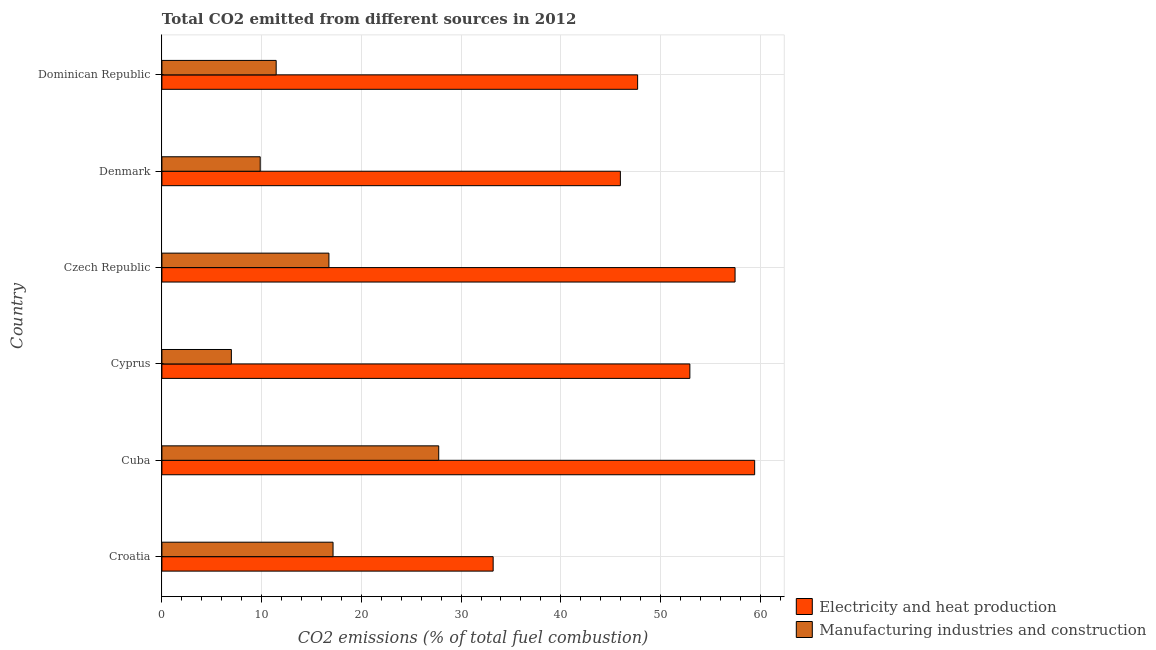How many groups of bars are there?
Provide a short and direct response. 6. Are the number of bars per tick equal to the number of legend labels?
Make the answer very short. Yes. Are the number of bars on each tick of the Y-axis equal?
Offer a very short reply. Yes. How many bars are there on the 2nd tick from the top?
Your answer should be compact. 2. What is the label of the 5th group of bars from the top?
Your answer should be very brief. Cuba. What is the co2 emissions due to manufacturing industries in Croatia?
Your answer should be compact. 17.16. Across all countries, what is the maximum co2 emissions due to electricity and heat production?
Ensure brevity in your answer.  59.44. Across all countries, what is the minimum co2 emissions due to manufacturing industries?
Your answer should be very brief. 6.97. In which country was the co2 emissions due to manufacturing industries maximum?
Offer a terse response. Cuba. In which country was the co2 emissions due to manufacturing industries minimum?
Offer a terse response. Cyprus. What is the total co2 emissions due to electricity and heat production in the graph?
Your response must be concise. 296.75. What is the difference between the co2 emissions due to manufacturing industries in Cyprus and that in Denmark?
Make the answer very short. -2.89. What is the difference between the co2 emissions due to manufacturing industries in Czech Republic and the co2 emissions due to electricity and heat production in Cyprus?
Make the answer very short. -36.19. What is the average co2 emissions due to electricity and heat production per country?
Your answer should be very brief. 49.46. What is the difference between the co2 emissions due to electricity and heat production and co2 emissions due to manufacturing industries in Cuba?
Your response must be concise. 31.68. In how many countries, is the co2 emissions due to electricity and heat production greater than 22 %?
Your answer should be very brief. 6. What is the ratio of the co2 emissions due to electricity and heat production in Cuba to that in Dominican Republic?
Your answer should be very brief. 1.25. Is the co2 emissions due to electricity and heat production in Croatia less than that in Dominican Republic?
Keep it short and to the point. Yes. Is the difference between the co2 emissions due to electricity and heat production in Cyprus and Dominican Republic greater than the difference between the co2 emissions due to manufacturing industries in Cyprus and Dominican Republic?
Provide a succinct answer. Yes. What is the difference between the highest and the second highest co2 emissions due to electricity and heat production?
Your response must be concise. 1.96. What is the difference between the highest and the lowest co2 emissions due to manufacturing industries?
Ensure brevity in your answer.  20.79. What does the 2nd bar from the top in Denmark represents?
Offer a very short reply. Electricity and heat production. What does the 2nd bar from the bottom in Croatia represents?
Give a very brief answer. Manufacturing industries and construction. How many countries are there in the graph?
Provide a short and direct response. 6. Does the graph contain any zero values?
Ensure brevity in your answer.  No. Does the graph contain grids?
Offer a terse response. Yes. How many legend labels are there?
Provide a succinct answer. 2. What is the title of the graph?
Make the answer very short. Total CO2 emitted from different sources in 2012. Does "Secondary school" appear as one of the legend labels in the graph?
Your answer should be compact. No. What is the label or title of the X-axis?
Offer a terse response. CO2 emissions (% of total fuel combustion). What is the CO2 emissions (% of total fuel combustion) of Electricity and heat production in Croatia?
Your answer should be very brief. 33.22. What is the CO2 emissions (% of total fuel combustion) of Manufacturing industries and construction in Croatia?
Provide a succinct answer. 17.16. What is the CO2 emissions (% of total fuel combustion) in Electricity and heat production in Cuba?
Keep it short and to the point. 59.44. What is the CO2 emissions (% of total fuel combustion) in Manufacturing industries and construction in Cuba?
Provide a short and direct response. 27.76. What is the CO2 emissions (% of total fuel combustion) of Electricity and heat production in Cyprus?
Your answer should be compact. 52.94. What is the CO2 emissions (% of total fuel combustion) of Manufacturing industries and construction in Cyprus?
Offer a terse response. 6.97. What is the CO2 emissions (% of total fuel combustion) of Electricity and heat production in Czech Republic?
Offer a terse response. 57.47. What is the CO2 emissions (% of total fuel combustion) of Manufacturing industries and construction in Czech Republic?
Give a very brief answer. 16.75. What is the CO2 emissions (% of total fuel combustion) in Electricity and heat production in Denmark?
Offer a very short reply. 45.97. What is the CO2 emissions (% of total fuel combustion) of Manufacturing industries and construction in Denmark?
Provide a succinct answer. 9.86. What is the CO2 emissions (% of total fuel combustion) in Electricity and heat production in Dominican Republic?
Your answer should be very brief. 47.7. What is the CO2 emissions (% of total fuel combustion) in Manufacturing industries and construction in Dominican Republic?
Keep it short and to the point. 11.46. Across all countries, what is the maximum CO2 emissions (% of total fuel combustion) in Electricity and heat production?
Offer a terse response. 59.44. Across all countries, what is the maximum CO2 emissions (% of total fuel combustion) of Manufacturing industries and construction?
Your response must be concise. 27.76. Across all countries, what is the minimum CO2 emissions (% of total fuel combustion) of Electricity and heat production?
Give a very brief answer. 33.22. Across all countries, what is the minimum CO2 emissions (% of total fuel combustion) in Manufacturing industries and construction?
Provide a succinct answer. 6.97. What is the total CO2 emissions (% of total fuel combustion) of Electricity and heat production in the graph?
Your answer should be compact. 296.75. What is the total CO2 emissions (% of total fuel combustion) in Manufacturing industries and construction in the graph?
Give a very brief answer. 89.95. What is the difference between the CO2 emissions (% of total fuel combustion) in Electricity and heat production in Croatia and that in Cuba?
Make the answer very short. -26.22. What is the difference between the CO2 emissions (% of total fuel combustion) of Manufacturing industries and construction in Croatia and that in Cuba?
Your answer should be compact. -10.6. What is the difference between the CO2 emissions (% of total fuel combustion) in Electricity and heat production in Croatia and that in Cyprus?
Your answer should be compact. -19.72. What is the difference between the CO2 emissions (% of total fuel combustion) of Manufacturing industries and construction in Croatia and that in Cyprus?
Offer a very short reply. 10.2. What is the difference between the CO2 emissions (% of total fuel combustion) in Electricity and heat production in Croatia and that in Czech Republic?
Your answer should be very brief. -24.26. What is the difference between the CO2 emissions (% of total fuel combustion) in Manufacturing industries and construction in Croatia and that in Czech Republic?
Offer a terse response. 0.41. What is the difference between the CO2 emissions (% of total fuel combustion) in Electricity and heat production in Croatia and that in Denmark?
Your answer should be very brief. -12.76. What is the difference between the CO2 emissions (% of total fuel combustion) in Manufacturing industries and construction in Croatia and that in Denmark?
Your answer should be compact. 7.3. What is the difference between the CO2 emissions (% of total fuel combustion) in Electricity and heat production in Croatia and that in Dominican Republic?
Make the answer very short. -14.49. What is the difference between the CO2 emissions (% of total fuel combustion) in Manufacturing industries and construction in Croatia and that in Dominican Republic?
Your response must be concise. 5.7. What is the difference between the CO2 emissions (% of total fuel combustion) in Electricity and heat production in Cuba and that in Cyprus?
Your answer should be compact. 6.5. What is the difference between the CO2 emissions (% of total fuel combustion) of Manufacturing industries and construction in Cuba and that in Cyprus?
Your response must be concise. 20.79. What is the difference between the CO2 emissions (% of total fuel combustion) of Electricity and heat production in Cuba and that in Czech Republic?
Make the answer very short. 1.96. What is the difference between the CO2 emissions (% of total fuel combustion) of Manufacturing industries and construction in Cuba and that in Czech Republic?
Provide a short and direct response. 11.01. What is the difference between the CO2 emissions (% of total fuel combustion) in Electricity and heat production in Cuba and that in Denmark?
Provide a short and direct response. 13.46. What is the difference between the CO2 emissions (% of total fuel combustion) in Manufacturing industries and construction in Cuba and that in Denmark?
Ensure brevity in your answer.  17.9. What is the difference between the CO2 emissions (% of total fuel combustion) of Electricity and heat production in Cuba and that in Dominican Republic?
Make the answer very short. 11.73. What is the difference between the CO2 emissions (% of total fuel combustion) of Manufacturing industries and construction in Cuba and that in Dominican Republic?
Provide a succinct answer. 16.3. What is the difference between the CO2 emissions (% of total fuel combustion) of Electricity and heat production in Cyprus and that in Czech Republic?
Make the answer very short. -4.53. What is the difference between the CO2 emissions (% of total fuel combustion) of Manufacturing industries and construction in Cyprus and that in Czech Republic?
Offer a terse response. -9.78. What is the difference between the CO2 emissions (% of total fuel combustion) of Electricity and heat production in Cyprus and that in Denmark?
Provide a short and direct response. 6.97. What is the difference between the CO2 emissions (% of total fuel combustion) of Manufacturing industries and construction in Cyprus and that in Denmark?
Your response must be concise. -2.89. What is the difference between the CO2 emissions (% of total fuel combustion) in Electricity and heat production in Cyprus and that in Dominican Republic?
Make the answer very short. 5.24. What is the difference between the CO2 emissions (% of total fuel combustion) of Manufacturing industries and construction in Cyprus and that in Dominican Republic?
Your answer should be very brief. -4.49. What is the difference between the CO2 emissions (% of total fuel combustion) of Electricity and heat production in Czech Republic and that in Denmark?
Offer a terse response. 11.5. What is the difference between the CO2 emissions (% of total fuel combustion) of Manufacturing industries and construction in Czech Republic and that in Denmark?
Offer a very short reply. 6.89. What is the difference between the CO2 emissions (% of total fuel combustion) of Electricity and heat production in Czech Republic and that in Dominican Republic?
Ensure brevity in your answer.  9.77. What is the difference between the CO2 emissions (% of total fuel combustion) in Manufacturing industries and construction in Czech Republic and that in Dominican Republic?
Provide a succinct answer. 5.29. What is the difference between the CO2 emissions (% of total fuel combustion) of Electricity and heat production in Denmark and that in Dominican Republic?
Offer a terse response. -1.73. What is the difference between the CO2 emissions (% of total fuel combustion) of Manufacturing industries and construction in Denmark and that in Dominican Republic?
Your response must be concise. -1.6. What is the difference between the CO2 emissions (% of total fuel combustion) in Electricity and heat production in Croatia and the CO2 emissions (% of total fuel combustion) in Manufacturing industries and construction in Cuba?
Provide a short and direct response. 5.46. What is the difference between the CO2 emissions (% of total fuel combustion) in Electricity and heat production in Croatia and the CO2 emissions (% of total fuel combustion) in Manufacturing industries and construction in Cyprus?
Your answer should be very brief. 26.25. What is the difference between the CO2 emissions (% of total fuel combustion) in Electricity and heat production in Croatia and the CO2 emissions (% of total fuel combustion) in Manufacturing industries and construction in Czech Republic?
Offer a terse response. 16.47. What is the difference between the CO2 emissions (% of total fuel combustion) in Electricity and heat production in Croatia and the CO2 emissions (% of total fuel combustion) in Manufacturing industries and construction in Denmark?
Provide a succinct answer. 23.36. What is the difference between the CO2 emissions (% of total fuel combustion) of Electricity and heat production in Croatia and the CO2 emissions (% of total fuel combustion) of Manufacturing industries and construction in Dominican Republic?
Keep it short and to the point. 21.76. What is the difference between the CO2 emissions (% of total fuel combustion) of Electricity and heat production in Cuba and the CO2 emissions (% of total fuel combustion) of Manufacturing industries and construction in Cyprus?
Your answer should be compact. 52.47. What is the difference between the CO2 emissions (% of total fuel combustion) of Electricity and heat production in Cuba and the CO2 emissions (% of total fuel combustion) of Manufacturing industries and construction in Czech Republic?
Provide a succinct answer. 42.69. What is the difference between the CO2 emissions (% of total fuel combustion) of Electricity and heat production in Cuba and the CO2 emissions (% of total fuel combustion) of Manufacturing industries and construction in Denmark?
Give a very brief answer. 49.58. What is the difference between the CO2 emissions (% of total fuel combustion) in Electricity and heat production in Cuba and the CO2 emissions (% of total fuel combustion) in Manufacturing industries and construction in Dominican Republic?
Give a very brief answer. 47.98. What is the difference between the CO2 emissions (% of total fuel combustion) in Electricity and heat production in Cyprus and the CO2 emissions (% of total fuel combustion) in Manufacturing industries and construction in Czech Republic?
Make the answer very short. 36.19. What is the difference between the CO2 emissions (% of total fuel combustion) in Electricity and heat production in Cyprus and the CO2 emissions (% of total fuel combustion) in Manufacturing industries and construction in Denmark?
Provide a succinct answer. 43.08. What is the difference between the CO2 emissions (% of total fuel combustion) of Electricity and heat production in Cyprus and the CO2 emissions (% of total fuel combustion) of Manufacturing industries and construction in Dominican Republic?
Provide a short and direct response. 41.48. What is the difference between the CO2 emissions (% of total fuel combustion) of Electricity and heat production in Czech Republic and the CO2 emissions (% of total fuel combustion) of Manufacturing industries and construction in Denmark?
Your answer should be very brief. 47.62. What is the difference between the CO2 emissions (% of total fuel combustion) of Electricity and heat production in Czech Republic and the CO2 emissions (% of total fuel combustion) of Manufacturing industries and construction in Dominican Republic?
Provide a short and direct response. 46.02. What is the difference between the CO2 emissions (% of total fuel combustion) in Electricity and heat production in Denmark and the CO2 emissions (% of total fuel combustion) in Manufacturing industries and construction in Dominican Republic?
Give a very brief answer. 34.51. What is the average CO2 emissions (% of total fuel combustion) of Electricity and heat production per country?
Ensure brevity in your answer.  49.46. What is the average CO2 emissions (% of total fuel combustion) of Manufacturing industries and construction per country?
Offer a terse response. 14.99. What is the difference between the CO2 emissions (% of total fuel combustion) of Electricity and heat production and CO2 emissions (% of total fuel combustion) of Manufacturing industries and construction in Croatia?
Make the answer very short. 16.06. What is the difference between the CO2 emissions (% of total fuel combustion) in Electricity and heat production and CO2 emissions (% of total fuel combustion) in Manufacturing industries and construction in Cuba?
Provide a short and direct response. 31.68. What is the difference between the CO2 emissions (% of total fuel combustion) of Electricity and heat production and CO2 emissions (% of total fuel combustion) of Manufacturing industries and construction in Cyprus?
Give a very brief answer. 45.98. What is the difference between the CO2 emissions (% of total fuel combustion) of Electricity and heat production and CO2 emissions (% of total fuel combustion) of Manufacturing industries and construction in Czech Republic?
Provide a short and direct response. 40.73. What is the difference between the CO2 emissions (% of total fuel combustion) of Electricity and heat production and CO2 emissions (% of total fuel combustion) of Manufacturing industries and construction in Denmark?
Offer a terse response. 36.12. What is the difference between the CO2 emissions (% of total fuel combustion) in Electricity and heat production and CO2 emissions (% of total fuel combustion) in Manufacturing industries and construction in Dominican Republic?
Give a very brief answer. 36.24. What is the ratio of the CO2 emissions (% of total fuel combustion) of Electricity and heat production in Croatia to that in Cuba?
Provide a succinct answer. 0.56. What is the ratio of the CO2 emissions (% of total fuel combustion) of Manufacturing industries and construction in Croatia to that in Cuba?
Your answer should be very brief. 0.62. What is the ratio of the CO2 emissions (% of total fuel combustion) of Electricity and heat production in Croatia to that in Cyprus?
Your answer should be very brief. 0.63. What is the ratio of the CO2 emissions (% of total fuel combustion) in Manufacturing industries and construction in Croatia to that in Cyprus?
Your answer should be very brief. 2.46. What is the ratio of the CO2 emissions (% of total fuel combustion) in Electricity and heat production in Croatia to that in Czech Republic?
Ensure brevity in your answer.  0.58. What is the ratio of the CO2 emissions (% of total fuel combustion) of Manufacturing industries and construction in Croatia to that in Czech Republic?
Provide a succinct answer. 1.02. What is the ratio of the CO2 emissions (% of total fuel combustion) in Electricity and heat production in Croatia to that in Denmark?
Provide a succinct answer. 0.72. What is the ratio of the CO2 emissions (% of total fuel combustion) of Manufacturing industries and construction in Croatia to that in Denmark?
Provide a succinct answer. 1.74. What is the ratio of the CO2 emissions (% of total fuel combustion) of Electricity and heat production in Croatia to that in Dominican Republic?
Provide a short and direct response. 0.7. What is the ratio of the CO2 emissions (% of total fuel combustion) of Manufacturing industries and construction in Croatia to that in Dominican Republic?
Keep it short and to the point. 1.5. What is the ratio of the CO2 emissions (% of total fuel combustion) in Electricity and heat production in Cuba to that in Cyprus?
Your response must be concise. 1.12. What is the ratio of the CO2 emissions (% of total fuel combustion) in Manufacturing industries and construction in Cuba to that in Cyprus?
Give a very brief answer. 3.98. What is the ratio of the CO2 emissions (% of total fuel combustion) in Electricity and heat production in Cuba to that in Czech Republic?
Ensure brevity in your answer.  1.03. What is the ratio of the CO2 emissions (% of total fuel combustion) of Manufacturing industries and construction in Cuba to that in Czech Republic?
Offer a terse response. 1.66. What is the ratio of the CO2 emissions (% of total fuel combustion) in Electricity and heat production in Cuba to that in Denmark?
Keep it short and to the point. 1.29. What is the ratio of the CO2 emissions (% of total fuel combustion) in Manufacturing industries and construction in Cuba to that in Denmark?
Your response must be concise. 2.82. What is the ratio of the CO2 emissions (% of total fuel combustion) of Electricity and heat production in Cuba to that in Dominican Republic?
Ensure brevity in your answer.  1.25. What is the ratio of the CO2 emissions (% of total fuel combustion) of Manufacturing industries and construction in Cuba to that in Dominican Republic?
Your answer should be compact. 2.42. What is the ratio of the CO2 emissions (% of total fuel combustion) in Electricity and heat production in Cyprus to that in Czech Republic?
Your answer should be very brief. 0.92. What is the ratio of the CO2 emissions (% of total fuel combustion) in Manufacturing industries and construction in Cyprus to that in Czech Republic?
Your answer should be very brief. 0.42. What is the ratio of the CO2 emissions (% of total fuel combustion) of Electricity and heat production in Cyprus to that in Denmark?
Keep it short and to the point. 1.15. What is the ratio of the CO2 emissions (% of total fuel combustion) of Manufacturing industries and construction in Cyprus to that in Denmark?
Offer a terse response. 0.71. What is the ratio of the CO2 emissions (% of total fuel combustion) of Electricity and heat production in Cyprus to that in Dominican Republic?
Keep it short and to the point. 1.11. What is the ratio of the CO2 emissions (% of total fuel combustion) of Manufacturing industries and construction in Cyprus to that in Dominican Republic?
Your response must be concise. 0.61. What is the ratio of the CO2 emissions (% of total fuel combustion) of Electricity and heat production in Czech Republic to that in Denmark?
Make the answer very short. 1.25. What is the ratio of the CO2 emissions (% of total fuel combustion) in Manufacturing industries and construction in Czech Republic to that in Denmark?
Your answer should be compact. 1.7. What is the ratio of the CO2 emissions (% of total fuel combustion) in Electricity and heat production in Czech Republic to that in Dominican Republic?
Your response must be concise. 1.2. What is the ratio of the CO2 emissions (% of total fuel combustion) of Manufacturing industries and construction in Czech Republic to that in Dominican Republic?
Give a very brief answer. 1.46. What is the ratio of the CO2 emissions (% of total fuel combustion) of Electricity and heat production in Denmark to that in Dominican Republic?
Keep it short and to the point. 0.96. What is the ratio of the CO2 emissions (% of total fuel combustion) of Manufacturing industries and construction in Denmark to that in Dominican Republic?
Offer a terse response. 0.86. What is the difference between the highest and the second highest CO2 emissions (% of total fuel combustion) in Electricity and heat production?
Provide a short and direct response. 1.96. What is the difference between the highest and the second highest CO2 emissions (% of total fuel combustion) of Manufacturing industries and construction?
Give a very brief answer. 10.6. What is the difference between the highest and the lowest CO2 emissions (% of total fuel combustion) of Electricity and heat production?
Keep it short and to the point. 26.22. What is the difference between the highest and the lowest CO2 emissions (% of total fuel combustion) in Manufacturing industries and construction?
Provide a short and direct response. 20.79. 